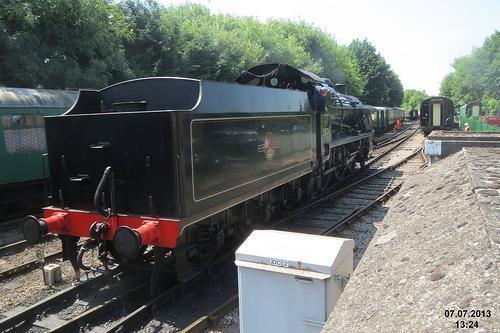How many white boxes are visible?
Give a very brief answer. 1. How many tracks are there?
Give a very brief answer. 4. How many trains are there?
Give a very brief answer. 3. 